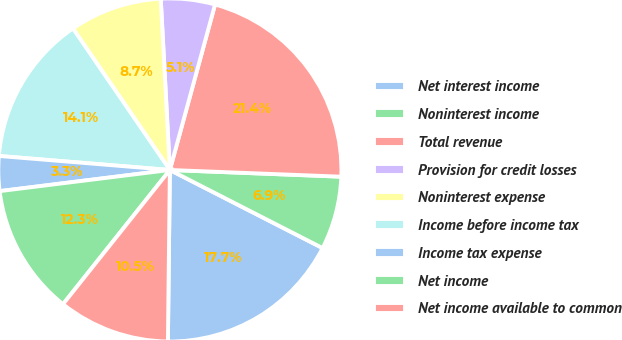Convert chart to OTSL. <chart><loc_0><loc_0><loc_500><loc_500><pie_chart><fcel>Net interest income<fcel>Noninterest income<fcel>Total revenue<fcel>Provision for credit losses<fcel>Noninterest expense<fcel>Income before income tax<fcel>Income tax expense<fcel>Net income<fcel>Net income available to common<nl><fcel>17.66%<fcel>6.9%<fcel>21.38%<fcel>5.09%<fcel>8.71%<fcel>14.14%<fcel>3.27%<fcel>12.33%<fcel>10.52%<nl></chart> 